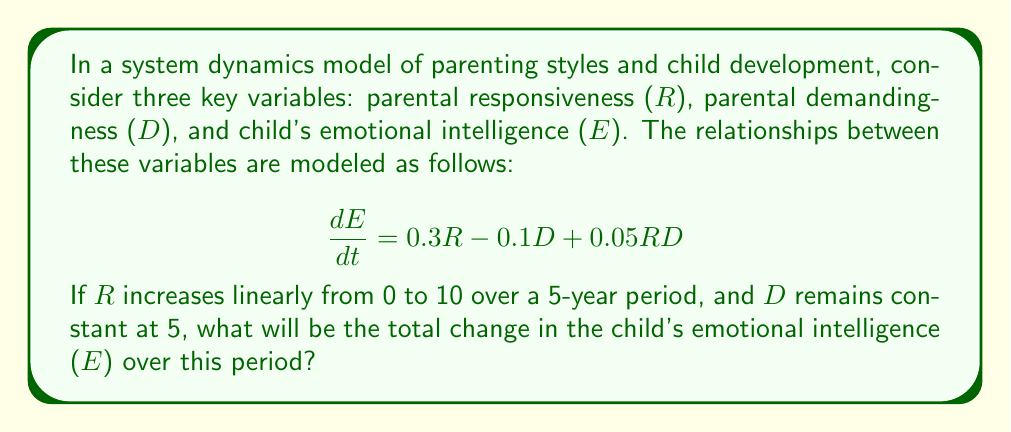Give your solution to this math problem. To solve this problem, we need to follow these steps:

1) First, we need to express R as a function of time t:
   $$R(t) = 2t$$ (since R increases from 0 to 10 over 5 years)

2) Now, we can substitute this and the constant D into our differential equation:
   $$\frac{dE}{dt} = 0.3(2t) - 0.1(5) + 0.05(2t)(5)$$
   $$\frac{dE}{dt} = 0.6t - 0.5 + 0.5t = 1.1t - 0.5$$

3) To find the total change in E, we need to integrate this equation from t=0 to t=5:
   $$\Delta E = \int_0^5 (1.1t - 0.5) dt$$

4) Integrating:
   $$\Delta E = [0.55t^2 - 0.5t]_0^5$$

5) Evaluating the integral:
   $$\Delta E = (0.55(5^2) - 0.5(5)) - (0.55(0^2) - 0.5(0))$$
   $$\Delta E = (13.75 - 2.5) - 0 = 11.25$$

Therefore, the total change in the child's emotional intelligence over the 5-year period is 11.25 units.
Answer: 11.25 